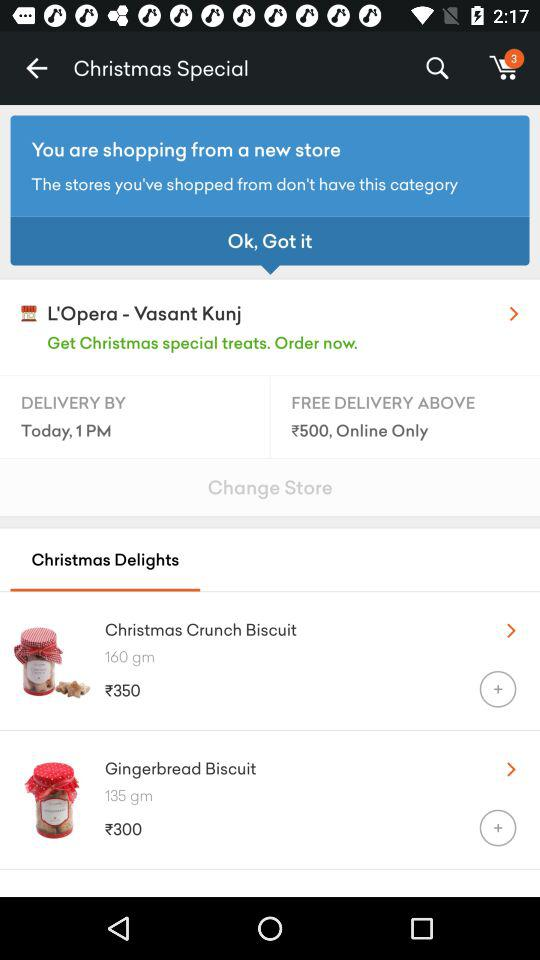What is the minimum purchase price for free delivery? The minimum purchase price is above ₹500. 